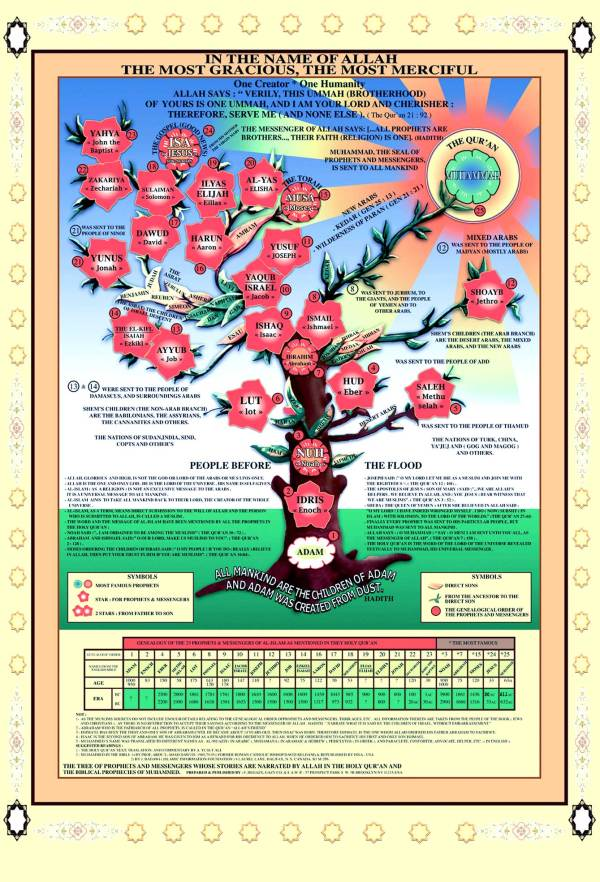What does the symbol at the top of the tree represent and how does it connect to the tree? The symbol at the top of the tree represents the Quran, the holy book of Islam. It signifies the culmination of the divine revelations received by the prophets, with Muhammad, who is located just below it on the tree, recognized as the final prophet who delivered the Quran. This placement emphasizes the Quran's role as a pinnacle of the spiritual and moral guidance provided through the line of prophets, symbolically crowning the tree and connecting all branches of prophetic teachings. 